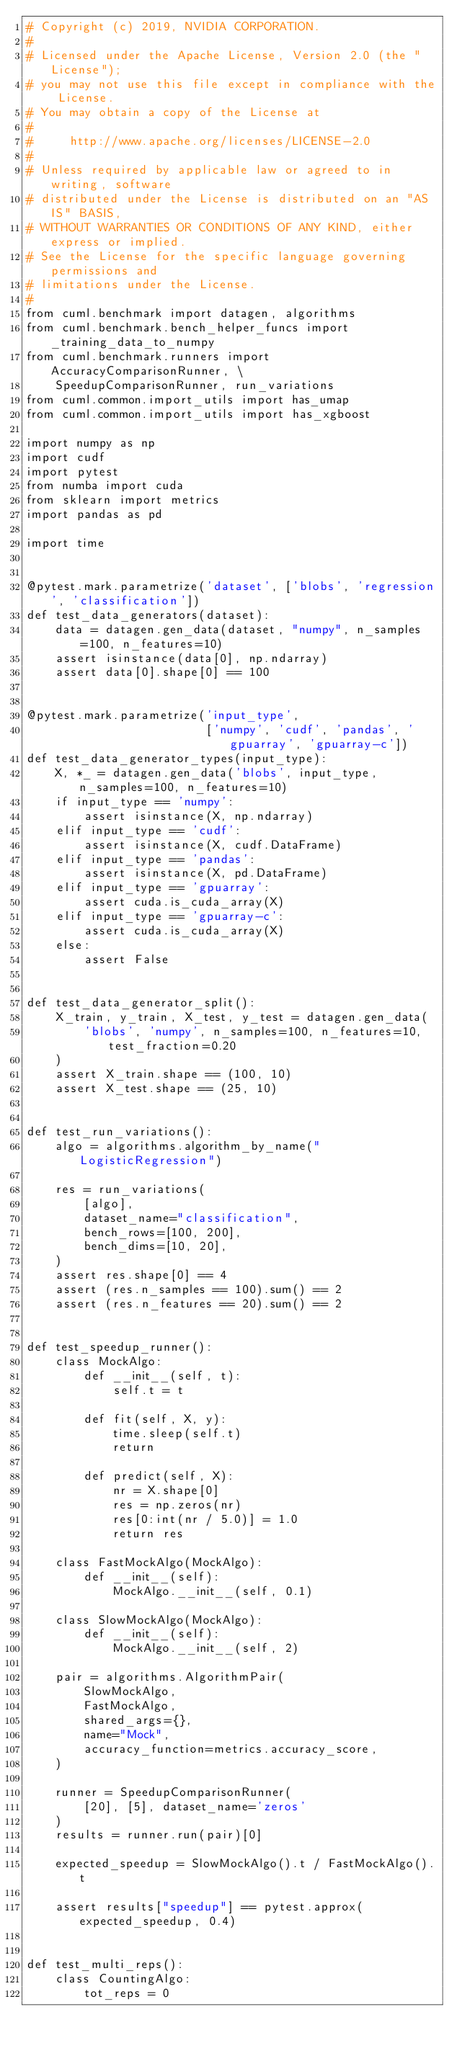Convert code to text. <code><loc_0><loc_0><loc_500><loc_500><_Python_># Copyright (c) 2019, NVIDIA CORPORATION.
#
# Licensed under the Apache License, Version 2.0 (the "License");
# you may not use this file except in compliance with the License.
# You may obtain a copy of the License at
#
#     http://www.apache.org/licenses/LICENSE-2.0
#
# Unless required by applicable law or agreed to in writing, software
# distributed under the License is distributed on an "AS IS" BASIS,
# WITHOUT WARRANTIES OR CONDITIONS OF ANY KIND, either express or implied.
# See the License for the specific language governing permissions and
# limitations under the License.
#
from cuml.benchmark import datagen, algorithms
from cuml.benchmark.bench_helper_funcs import _training_data_to_numpy
from cuml.benchmark.runners import AccuracyComparisonRunner, \
    SpeedupComparisonRunner, run_variations
from cuml.common.import_utils import has_umap
from cuml.common.import_utils import has_xgboost

import numpy as np
import cudf
import pytest
from numba import cuda
from sklearn import metrics
import pandas as pd

import time


@pytest.mark.parametrize('dataset', ['blobs', 'regression', 'classification'])
def test_data_generators(dataset):
    data = datagen.gen_data(dataset, "numpy", n_samples=100, n_features=10)
    assert isinstance(data[0], np.ndarray)
    assert data[0].shape[0] == 100


@pytest.mark.parametrize('input_type',
                         ['numpy', 'cudf', 'pandas', 'gpuarray', 'gpuarray-c'])
def test_data_generator_types(input_type):
    X, *_ = datagen.gen_data('blobs', input_type, n_samples=100, n_features=10)
    if input_type == 'numpy':
        assert isinstance(X, np.ndarray)
    elif input_type == 'cudf':
        assert isinstance(X, cudf.DataFrame)
    elif input_type == 'pandas':
        assert isinstance(X, pd.DataFrame)
    elif input_type == 'gpuarray':
        assert cuda.is_cuda_array(X)
    elif input_type == 'gpuarray-c':
        assert cuda.is_cuda_array(X)
    else:
        assert False


def test_data_generator_split():
    X_train, y_train, X_test, y_test = datagen.gen_data(
        'blobs', 'numpy', n_samples=100, n_features=10, test_fraction=0.20
    )
    assert X_train.shape == (100, 10)
    assert X_test.shape == (25, 10)


def test_run_variations():
    algo = algorithms.algorithm_by_name("LogisticRegression")

    res = run_variations(
        [algo],
        dataset_name="classification",
        bench_rows=[100, 200],
        bench_dims=[10, 20],
    )
    assert res.shape[0] == 4
    assert (res.n_samples == 100).sum() == 2
    assert (res.n_features == 20).sum() == 2


def test_speedup_runner():
    class MockAlgo:
        def __init__(self, t):
            self.t = t

        def fit(self, X, y):
            time.sleep(self.t)
            return

        def predict(self, X):
            nr = X.shape[0]
            res = np.zeros(nr)
            res[0:int(nr / 5.0)] = 1.0
            return res

    class FastMockAlgo(MockAlgo):
        def __init__(self):
            MockAlgo.__init__(self, 0.1)

    class SlowMockAlgo(MockAlgo):
        def __init__(self):
            MockAlgo.__init__(self, 2)

    pair = algorithms.AlgorithmPair(
        SlowMockAlgo,
        FastMockAlgo,
        shared_args={},
        name="Mock",
        accuracy_function=metrics.accuracy_score,
    )

    runner = SpeedupComparisonRunner(
        [20], [5], dataset_name='zeros'
    )
    results = runner.run(pair)[0]

    expected_speedup = SlowMockAlgo().t / FastMockAlgo().t

    assert results["speedup"] == pytest.approx(expected_speedup, 0.4)


def test_multi_reps():
    class CountingAlgo:
        tot_reps = 0
</code> 